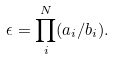Convert formula to latex. <formula><loc_0><loc_0><loc_500><loc_500>\epsilon = \prod _ { i } ^ { N } ( a _ { i } / b _ { i } ) .</formula> 